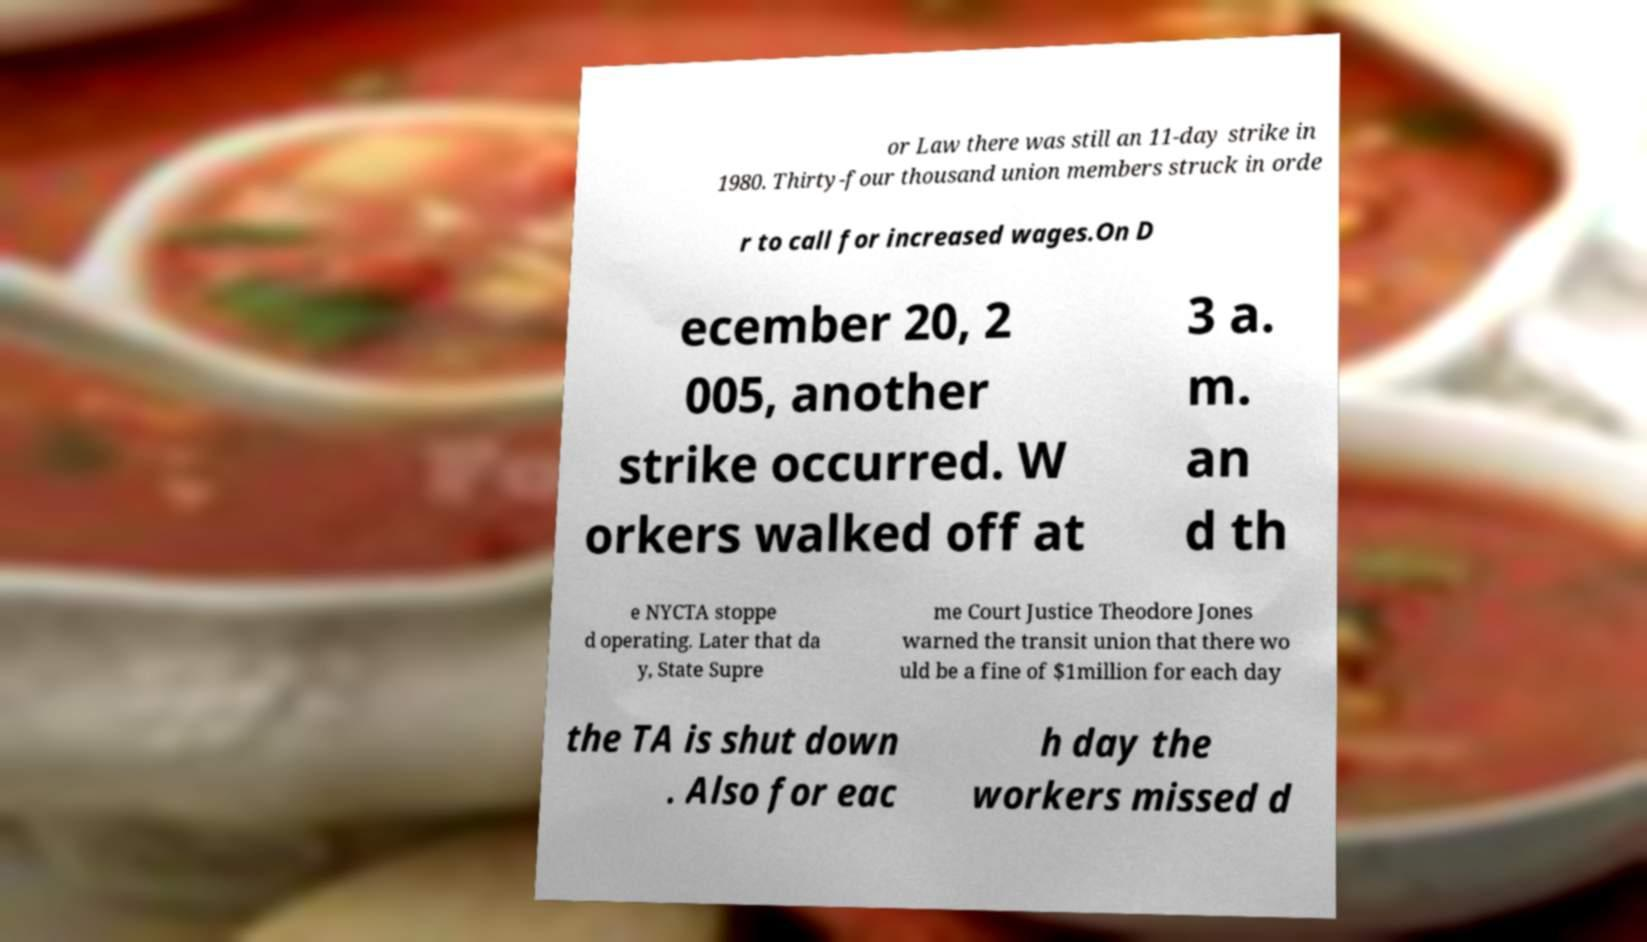For documentation purposes, I need the text within this image transcribed. Could you provide that? or Law there was still an 11-day strike in 1980. Thirty-four thousand union members struck in orde r to call for increased wages.On D ecember 20, 2 005, another strike occurred. W orkers walked off at 3 a. m. an d th e NYCTA stoppe d operating. Later that da y, State Supre me Court Justice Theodore Jones warned the transit union that there wo uld be a fine of $1million for each day the TA is shut down . Also for eac h day the workers missed d 